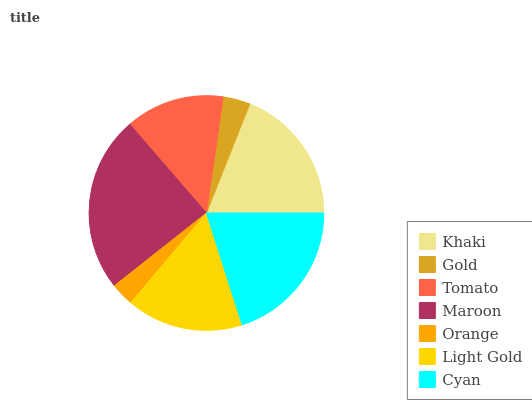Is Orange the minimum?
Answer yes or no. Yes. Is Maroon the maximum?
Answer yes or no. Yes. Is Gold the minimum?
Answer yes or no. No. Is Gold the maximum?
Answer yes or no. No. Is Khaki greater than Gold?
Answer yes or no. Yes. Is Gold less than Khaki?
Answer yes or no. Yes. Is Gold greater than Khaki?
Answer yes or no. No. Is Khaki less than Gold?
Answer yes or no. No. Is Light Gold the high median?
Answer yes or no. Yes. Is Light Gold the low median?
Answer yes or no. Yes. Is Maroon the high median?
Answer yes or no. No. Is Khaki the low median?
Answer yes or no. No. 